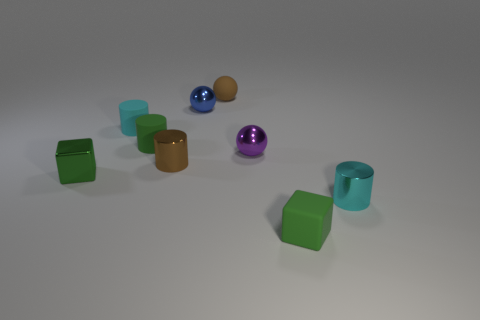What is the material of the other small cube that is the same color as the small matte block?
Give a very brief answer. Metal. There is a small green block that is behind the tiny cyan shiny cylinder; what material is it?
Give a very brief answer. Metal. How many large red spheres have the same material as the small green cylinder?
Your answer should be compact. 0. What is the shape of the metal object that is both right of the brown sphere and to the left of the small green rubber cube?
Provide a succinct answer. Sphere. What number of things are either tiny shiny things that are in front of the small metal cube or small cyan objects left of the tiny purple ball?
Give a very brief answer. 2. Is the number of rubber blocks on the right side of the tiny brown matte ball the same as the number of tiny rubber blocks that are on the left side of the metal block?
Your answer should be compact. No. There is a small green rubber thing in front of the cylinder that is in front of the brown metallic cylinder; what shape is it?
Give a very brief answer. Cube. Are there any brown objects of the same shape as the purple shiny object?
Offer a very short reply. Yes. What number of purple things are there?
Make the answer very short. 1. Are the cyan cylinder left of the brown matte ball and the blue object made of the same material?
Your answer should be very brief. No. 